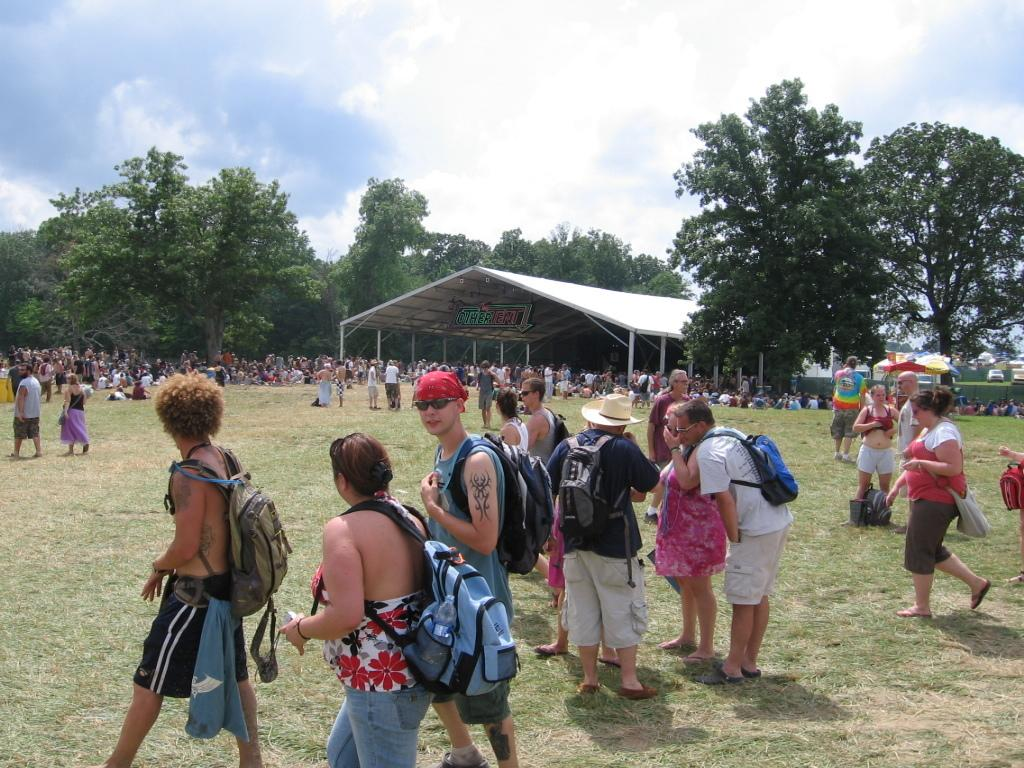How many people are in the group that is visible in the image? There is a group of people standing in the image, but the exact number cannot be determined from the provided facts. What type of structure can be seen in the image? There is a shed in the image. What type of vegetation is present in the image? There are trees in the image. What is visible in the background of the image? The sky is visible in the background of the image. Can you tell me which chess piece is being played by the person standing on the left side of the image? There is no chess piece or game visible in the image; it only features a group of people, a shed, trees, and the sky. 